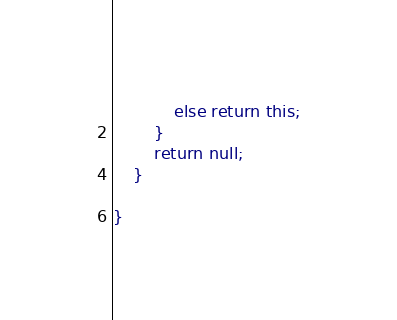<code> <loc_0><loc_0><loc_500><loc_500><_Java_>			else return this;
		}
		return null;
    }

}
</code> 